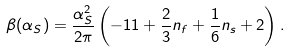Convert formula to latex. <formula><loc_0><loc_0><loc_500><loc_500>\beta ( \alpha _ { S } ) = \frac { \alpha _ { S } ^ { 2 } } { 2 \pi } \left ( - 1 1 + \frac { 2 } { 3 } n _ { f } + \frac { 1 } { 6 } n _ { s } + 2 \right ) .</formula> 